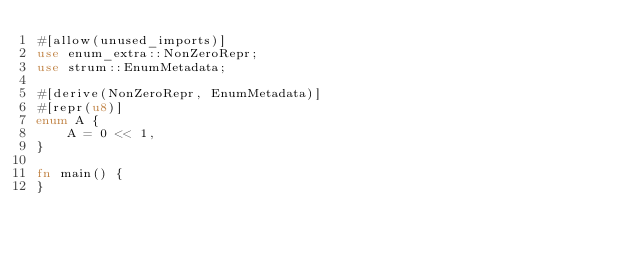Convert code to text. <code><loc_0><loc_0><loc_500><loc_500><_Rust_>#[allow(unused_imports)]
use enum_extra::NonZeroRepr;
use strum::EnumMetadata;

#[derive(NonZeroRepr, EnumMetadata)]
#[repr(u8)]
enum A {
    A = 0 << 1,
}

fn main() {
}


</code> 